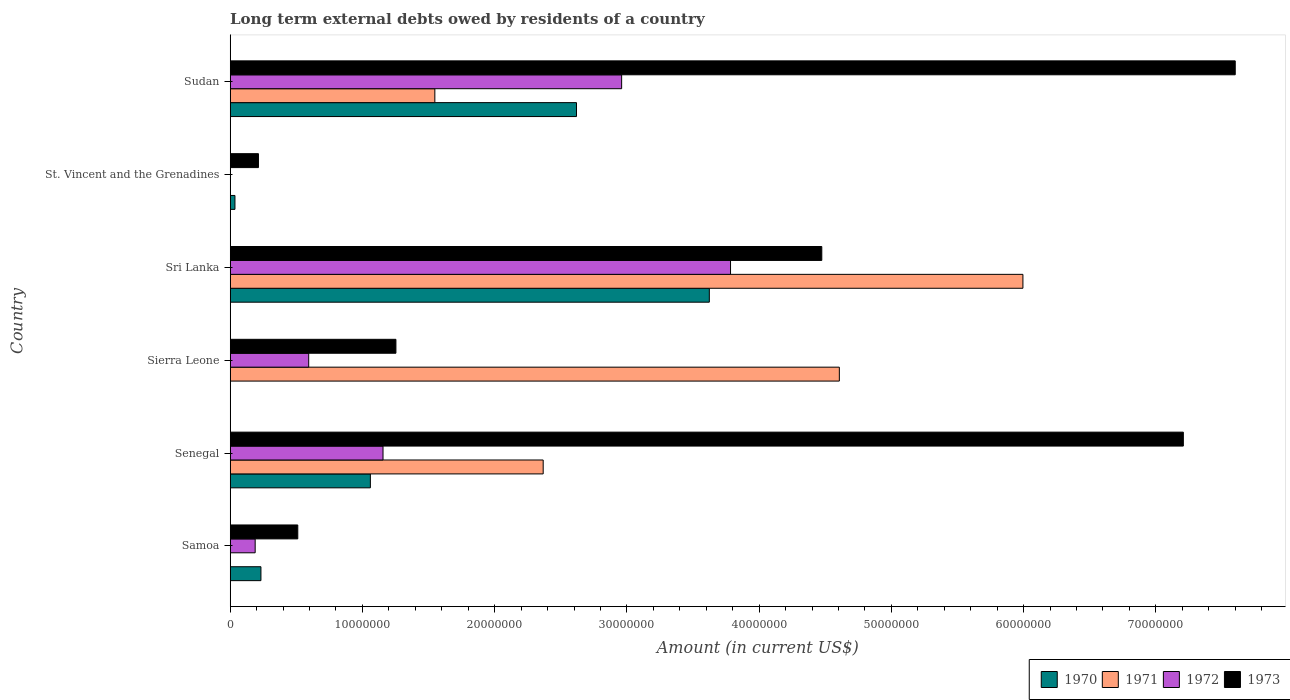Are the number of bars per tick equal to the number of legend labels?
Provide a succinct answer. No. How many bars are there on the 6th tick from the top?
Make the answer very short. 3. How many bars are there on the 3rd tick from the bottom?
Ensure brevity in your answer.  3. What is the label of the 4th group of bars from the top?
Make the answer very short. Sierra Leone. What is the amount of long-term external debts owed by residents in 1973 in Sudan?
Offer a very short reply. 7.60e+07. Across all countries, what is the maximum amount of long-term external debts owed by residents in 1970?
Make the answer very short. 3.62e+07. Across all countries, what is the minimum amount of long-term external debts owed by residents in 1970?
Give a very brief answer. 0. In which country was the amount of long-term external debts owed by residents in 1973 maximum?
Keep it short and to the point. Sudan. What is the total amount of long-term external debts owed by residents in 1971 in the graph?
Offer a very short reply. 1.45e+08. What is the difference between the amount of long-term external debts owed by residents in 1973 in Samoa and that in Sierra Leone?
Provide a succinct answer. -7.42e+06. What is the difference between the amount of long-term external debts owed by residents in 1973 in Sierra Leone and the amount of long-term external debts owed by residents in 1970 in Sri Lanka?
Your answer should be very brief. -2.37e+07. What is the average amount of long-term external debts owed by residents in 1970 per country?
Give a very brief answer. 1.26e+07. What is the difference between the amount of long-term external debts owed by residents in 1971 and amount of long-term external debts owed by residents in 1972 in Sri Lanka?
Your answer should be very brief. 2.21e+07. What is the ratio of the amount of long-term external debts owed by residents in 1972 in St. Vincent and the Grenadines to that in Sudan?
Provide a succinct answer. 0. Is the amount of long-term external debts owed by residents in 1970 in Sri Lanka less than that in Sudan?
Ensure brevity in your answer.  No. What is the difference between the highest and the second highest amount of long-term external debts owed by residents in 1972?
Offer a very short reply. 8.23e+06. What is the difference between the highest and the lowest amount of long-term external debts owed by residents in 1973?
Make the answer very short. 7.39e+07. In how many countries, is the amount of long-term external debts owed by residents in 1971 greater than the average amount of long-term external debts owed by residents in 1971 taken over all countries?
Your answer should be compact. 2. Is the sum of the amount of long-term external debts owed by residents in 1972 in Samoa and Senegal greater than the maximum amount of long-term external debts owed by residents in 1970 across all countries?
Your answer should be very brief. No. Is it the case that in every country, the sum of the amount of long-term external debts owed by residents in 1971 and amount of long-term external debts owed by residents in 1973 is greater than the sum of amount of long-term external debts owed by residents in 1970 and amount of long-term external debts owed by residents in 1972?
Give a very brief answer. No. Is it the case that in every country, the sum of the amount of long-term external debts owed by residents in 1972 and amount of long-term external debts owed by residents in 1971 is greater than the amount of long-term external debts owed by residents in 1970?
Your answer should be very brief. No. How many bars are there?
Your answer should be compact. 22. What is the difference between two consecutive major ticks on the X-axis?
Offer a very short reply. 1.00e+07. Are the values on the major ticks of X-axis written in scientific E-notation?
Offer a terse response. No. Does the graph contain any zero values?
Offer a very short reply. Yes. Does the graph contain grids?
Your answer should be very brief. No. How are the legend labels stacked?
Your answer should be compact. Horizontal. What is the title of the graph?
Your answer should be compact. Long term external debts owed by residents of a country. Does "1965" appear as one of the legend labels in the graph?
Ensure brevity in your answer.  No. What is the label or title of the Y-axis?
Offer a terse response. Country. What is the Amount (in current US$) in 1970 in Samoa?
Provide a succinct answer. 2.32e+06. What is the Amount (in current US$) of 1971 in Samoa?
Provide a short and direct response. 0. What is the Amount (in current US$) of 1972 in Samoa?
Your response must be concise. 1.89e+06. What is the Amount (in current US$) of 1973 in Samoa?
Provide a short and direct response. 5.11e+06. What is the Amount (in current US$) in 1970 in Senegal?
Give a very brief answer. 1.06e+07. What is the Amount (in current US$) in 1971 in Senegal?
Provide a short and direct response. 2.37e+07. What is the Amount (in current US$) in 1972 in Senegal?
Keep it short and to the point. 1.16e+07. What is the Amount (in current US$) of 1973 in Senegal?
Make the answer very short. 7.21e+07. What is the Amount (in current US$) of 1970 in Sierra Leone?
Your response must be concise. 0. What is the Amount (in current US$) of 1971 in Sierra Leone?
Provide a short and direct response. 4.61e+07. What is the Amount (in current US$) in 1972 in Sierra Leone?
Your answer should be very brief. 5.94e+06. What is the Amount (in current US$) of 1973 in Sierra Leone?
Provide a short and direct response. 1.25e+07. What is the Amount (in current US$) in 1970 in Sri Lanka?
Make the answer very short. 3.62e+07. What is the Amount (in current US$) of 1971 in Sri Lanka?
Give a very brief answer. 5.99e+07. What is the Amount (in current US$) in 1972 in Sri Lanka?
Provide a succinct answer. 3.78e+07. What is the Amount (in current US$) in 1973 in Sri Lanka?
Make the answer very short. 4.47e+07. What is the Amount (in current US$) in 1970 in St. Vincent and the Grenadines?
Ensure brevity in your answer.  3.60e+05. What is the Amount (in current US$) of 1971 in St. Vincent and the Grenadines?
Give a very brief answer. 3000. What is the Amount (in current US$) in 1972 in St. Vincent and the Grenadines?
Provide a succinct answer. 1.50e+04. What is the Amount (in current US$) of 1973 in St. Vincent and the Grenadines?
Your response must be concise. 2.14e+06. What is the Amount (in current US$) in 1970 in Sudan?
Your answer should be compact. 2.62e+07. What is the Amount (in current US$) in 1971 in Sudan?
Your answer should be compact. 1.55e+07. What is the Amount (in current US$) of 1972 in Sudan?
Offer a very short reply. 2.96e+07. What is the Amount (in current US$) in 1973 in Sudan?
Your answer should be very brief. 7.60e+07. Across all countries, what is the maximum Amount (in current US$) in 1970?
Your answer should be compact. 3.62e+07. Across all countries, what is the maximum Amount (in current US$) in 1971?
Provide a short and direct response. 5.99e+07. Across all countries, what is the maximum Amount (in current US$) in 1972?
Give a very brief answer. 3.78e+07. Across all countries, what is the maximum Amount (in current US$) in 1973?
Ensure brevity in your answer.  7.60e+07. Across all countries, what is the minimum Amount (in current US$) of 1971?
Your response must be concise. 0. Across all countries, what is the minimum Amount (in current US$) in 1972?
Your answer should be very brief. 1.50e+04. Across all countries, what is the minimum Amount (in current US$) in 1973?
Offer a terse response. 2.14e+06. What is the total Amount (in current US$) of 1970 in the graph?
Your answer should be compact. 7.57e+07. What is the total Amount (in current US$) of 1971 in the graph?
Offer a terse response. 1.45e+08. What is the total Amount (in current US$) of 1972 in the graph?
Offer a terse response. 8.68e+07. What is the total Amount (in current US$) in 1973 in the graph?
Provide a short and direct response. 2.13e+08. What is the difference between the Amount (in current US$) of 1970 in Samoa and that in Senegal?
Your answer should be very brief. -8.28e+06. What is the difference between the Amount (in current US$) in 1972 in Samoa and that in Senegal?
Make the answer very short. -9.67e+06. What is the difference between the Amount (in current US$) in 1973 in Samoa and that in Senegal?
Your answer should be very brief. -6.70e+07. What is the difference between the Amount (in current US$) in 1972 in Samoa and that in Sierra Leone?
Your response must be concise. -4.05e+06. What is the difference between the Amount (in current US$) of 1973 in Samoa and that in Sierra Leone?
Ensure brevity in your answer.  -7.42e+06. What is the difference between the Amount (in current US$) of 1970 in Samoa and that in Sri Lanka?
Offer a terse response. -3.39e+07. What is the difference between the Amount (in current US$) of 1972 in Samoa and that in Sri Lanka?
Your answer should be very brief. -3.59e+07. What is the difference between the Amount (in current US$) in 1973 in Samoa and that in Sri Lanka?
Your answer should be compact. -3.96e+07. What is the difference between the Amount (in current US$) of 1970 in Samoa and that in St. Vincent and the Grenadines?
Your answer should be compact. 1.96e+06. What is the difference between the Amount (in current US$) of 1972 in Samoa and that in St. Vincent and the Grenadines?
Provide a short and direct response. 1.87e+06. What is the difference between the Amount (in current US$) in 1973 in Samoa and that in St. Vincent and the Grenadines?
Your answer should be compact. 2.97e+06. What is the difference between the Amount (in current US$) in 1970 in Samoa and that in Sudan?
Your response must be concise. -2.39e+07. What is the difference between the Amount (in current US$) in 1972 in Samoa and that in Sudan?
Keep it short and to the point. -2.77e+07. What is the difference between the Amount (in current US$) of 1973 in Samoa and that in Sudan?
Provide a succinct answer. -7.09e+07. What is the difference between the Amount (in current US$) of 1971 in Senegal and that in Sierra Leone?
Keep it short and to the point. -2.24e+07. What is the difference between the Amount (in current US$) in 1972 in Senegal and that in Sierra Leone?
Your answer should be compact. 5.62e+06. What is the difference between the Amount (in current US$) in 1973 in Senegal and that in Sierra Leone?
Ensure brevity in your answer.  5.95e+07. What is the difference between the Amount (in current US$) in 1970 in Senegal and that in Sri Lanka?
Ensure brevity in your answer.  -2.56e+07. What is the difference between the Amount (in current US$) of 1971 in Senegal and that in Sri Lanka?
Your answer should be compact. -3.63e+07. What is the difference between the Amount (in current US$) in 1972 in Senegal and that in Sri Lanka?
Offer a terse response. -2.63e+07. What is the difference between the Amount (in current US$) in 1973 in Senegal and that in Sri Lanka?
Your response must be concise. 2.73e+07. What is the difference between the Amount (in current US$) of 1970 in Senegal and that in St. Vincent and the Grenadines?
Your answer should be very brief. 1.02e+07. What is the difference between the Amount (in current US$) of 1971 in Senegal and that in St. Vincent and the Grenadines?
Offer a very short reply. 2.37e+07. What is the difference between the Amount (in current US$) of 1972 in Senegal and that in St. Vincent and the Grenadines?
Provide a short and direct response. 1.15e+07. What is the difference between the Amount (in current US$) of 1973 in Senegal and that in St. Vincent and the Grenadines?
Provide a short and direct response. 6.99e+07. What is the difference between the Amount (in current US$) of 1970 in Senegal and that in Sudan?
Your answer should be compact. -1.56e+07. What is the difference between the Amount (in current US$) in 1971 in Senegal and that in Sudan?
Make the answer very short. 8.19e+06. What is the difference between the Amount (in current US$) of 1972 in Senegal and that in Sudan?
Your answer should be compact. -1.80e+07. What is the difference between the Amount (in current US$) in 1973 in Senegal and that in Sudan?
Provide a succinct answer. -3.92e+06. What is the difference between the Amount (in current US$) of 1971 in Sierra Leone and that in Sri Lanka?
Your answer should be compact. -1.39e+07. What is the difference between the Amount (in current US$) in 1972 in Sierra Leone and that in Sri Lanka?
Offer a very short reply. -3.19e+07. What is the difference between the Amount (in current US$) of 1973 in Sierra Leone and that in Sri Lanka?
Give a very brief answer. -3.22e+07. What is the difference between the Amount (in current US$) of 1971 in Sierra Leone and that in St. Vincent and the Grenadines?
Your answer should be very brief. 4.61e+07. What is the difference between the Amount (in current US$) in 1972 in Sierra Leone and that in St. Vincent and the Grenadines?
Ensure brevity in your answer.  5.92e+06. What is the difference between the Amount (in current US$) in 1973 in Sierra Leone and that in St. Vincent and the Grenadines?
Your response must be concise. 1.04e+07. What is the difference between the Amount (in current US$) of 1971 in Sierra Leone and that in Sudan?
Your answer should be very brief. 3.06e+07. What is the difference between the Amount (in current US$) in 1972 in Sierra Leone and that in Sudan?
Your answer should be very brief. -2.37e+07. What is the difference between the Amount (in current US$) of 1973 in Sierra Leone and that in Sudan?
Ensure brevity in your answer.  -6.35e+07. What is the difference between the Amount (in current US$) of 1970 in Sri Lanka and that in St. Vincent and the Grenadines?
Ensure brevity in your answer.  3.59e+07. What is the difference between the Amount (in current US$) of 1971 in Sri Lanka and that in St. Vincent and the Grenadines?
Give a very brief answer. 5.99e+07. What is the difference between the Amount (in current US$) in 1972 in Sri Lanka and that in St. Vincent and the Grenadines?
Your answer should be very brief. 3.78e+07. What is the difference between the Amount (in current US$) in 1973 in Sri Lanka and that in St. Vincent and the Grenadines?
Your response must be concise. 4.26e+07. What is the difference between the Amount (in current US$) in 1970 in Sri Lanka and that in Sudan?
Provide a short and direct response. 1.00e+07. What is the difference between the Amount (in current US$) of 1971 in Sri Lanka and that in Sudan?
Give a very brief answer. 4.45e+07. What is the difference between the Amount (in current US$) in 1972 in Sri Lanka and that in Sudan?
Provide a succinct answer. 8.23e+06. What is the difference between the Amount (in current US$) in 1973 in Sri Lanka and that in Sudan?
Offer a terse response. -3.13e+07. What is the difference between the Amount (in current US$) of 1970 in St. Vincent and the Grenadines and that in Sudan?
Make the answer very short. -2.58e+07. What is the difference between the Amount (in current US$) of 1971 in St. Vincent and the Grenadines and that in Sudan?
Offer a very short reply. -1.55e+07. What is the difference between the Amount (in current US$) of 1972 in St. Vincent and the Grenadines and that in Sudan?
Your answer should be compact. -2.96e+07. What is the difference between the Amount (in current US$) in 1973 in St. Vincent and the Grenadines and that in Sudan?
Your answer should be compact. -7.39e+07. What is the difference between the Amount (in current US$) in 1970 in Samoa and the Amount (in current US$) in 1971 in Senegal?
Keep it short and to the point. -2.13e+07. What is the difference between the Amount (in current US$) of 1970 in Samoa and the Amount (in current US$) of 1972 in Senegal?
Provide a short and direct response. -9.23e+06. What is the difference between the Amount (in current US$) of 1970 in Samoa and the Amount (in current US$) of 1973 in Senegal?
Your answer should be compact. -6.98e+07. What is the difference between the Amount (in current US$) in 1972 in Samoa and the Amount (in current US$) in 1973 in Senegal?
Offer a terse response. -7.02e+07. What is the difference between the Amount (in current US$) in 1970 in Samoa and the Amount (in current US$) in 1971 in Sierra Leone?
Keep it short and to the point. -4.37e+07. What is the difference between the Amount (in current US$) of 1970 in Samoa and the Amount (in current US$) of 1972 in Sierra Leone?
Offer a very short reply. -3.61e+06. What is the difference between the Amount (in current US$) in 1970 in Samoa and the Amount (in current US$) in 1973 in Sierra Leone?
Ensure brevity in your answer.  -1.02e+07. What is the difference between the Amount (in current US$) of 1972 in Samoa and the Amount (in current US$) of 1973 in Sierra Leone?
Make the answer very short. -1.06e+07. What is the difference between the Amount (in current US$) of 1970 in Samoa and the Amount (in current US$) of 1971 in Sri Lanka?
Your response must be concise. -5.76e+07. What is the difference between the Amount (in current US$) of 1970 in Samoa and the Amount (in current US$) of 1972 in Sri Lanka?
Your answer should be very brief. -3.55e+07. What is the difference between the Amount (in current US$) in 1970 in Samoa and the Amount (in current US$) in 1973 in Sri Lanka?
Ensure brevity in your answer.  -4.24e+07. What is the difference between the Amount (in current US$) of 1972 in Samoa and the Amount (in current US$) of 1973 in Sri Lanka?
Offer a terse response. -4.28e+07. What is the difference between the Amount (in current US$) of 1970 in Samoa and the Amount (in current US$) of 1971 in St. Vincent and the Grenadines?
Ensure brevity in your answer.  2.32e+06. What is the difference between the Amount (in current US$) of 1970 in Samoa and the Amount (in current US$) of 1972 in St. Vincent and the Grenadines?
Ensure brevity in your answer.  2.31e+06. What is the difference between the Amount (in current US$) in 1970 in Samoa and the Amount (in current US$) in 1973 in St. Vincent and the Grenadines?
Keep it short and to the point. 1.88e+05. What is the difference between the Amount (in current US$) of 1972 in Samoa and the Amount (in current US$) of 1973 in St. Vincent and the Grenadines?
Keep it short and to the point. -2.48e+05. What is the difference between the Amount (in current US$) of 1970 in Samoa and the Amount (in current US$) of 1971 in Sudan?
Your answer should be very brief. -1.32e+07. What is the difference between the Amount (in current US$) of 1970 in Samoa and the Amount (in current US$) of 1972 in Sudan?
Give a very brief answer. -2.73e+07. What is the difference between the Amount (in current US$) in 1970 in Samoa and the Amount (in current US$) in 1973 in Sudan?
Your response must be concise. -7.37e+07. What is the difference between the Amount (in current US$) in 1972 in Samoa and the Amount (in current US$) in 1973 in Sudan?
Provide a short and direct response. -7.41e+07. What is the difference between the Amount (in current US$) of 1970 in Senegal and the Amount (in current US$) of 1971 in Sierra Leone?
Offer a terse response. -3.55e+07. What is the difference between the Amount (in current US$) of 1970 in Senegal and the Amount (in current US$) of 1972 in Sierra Leone?
Ensure brevity in your answer.  4.66e+06. What is the difference between the Amount (in current US$) in 1970 in Senegal and the Amount (in current US$) in 1973 in Sierra Leone?
Your answer should be compact. -1.93e+06. What is the difference between the Amount (in current US$) in 1971 in Senegal and the Amount (in current US$) in 1972 in Sierra Leone?
Keep it short and to the point. 1.77e+07. What is the difference between the Amount (in current US$) in 1971 in Senegal and the Amount (in current US$) in 1973 in Sierra Leone?
Offer a terse response. 1.11e+07. What is the difference between the Amount (in current US$) in 1972 in Senegal and the Amount (in current US$) in 1973 in Sierra Leone?
Your answer should be very brief. -9.76e+05. What is the difference between the Amount (in current US$) in 1970 in Senegal and the Amount (in current US$) in 1971 in Sri Lanka?
Keep it short and to the point. -4.93e+07. What is the difference between the Amount (in current US$) of 1970 in Senegal and the Amount (in current US$) of 1972 in Sri Lanka?
Ensure brevity in your answer.  -2.72e+07. What is the difference between the Amount (in current US$) in 1970 in Senegal and the Amount (in current US$) in 1973 in Sri Lanka?
Provide a succinct answer. -3.41e+07. What is the difference between the Amount (in current US$) in 1971 in Senegal and the Amount (in current US$) in 1972 in Sri Lanka?
Offer a very short reply. -1.42e+07. What is the difference between the Amount (in current US$) in 1971 in Senegal and the Amount (in current US$) in 1973 in Sri Lanka?
Ensure brevity in your answer.  -2.11e+07. What is the difference between the Amount (in current US$) of 1972 in Senegal and the Amount (in current US$) of 1973 in Sri Lanka?
Provide a short and direct response. -3.32e+07. What is the difference between the Amount (in current US$) of 1970 in Senegal and the Amount (in current US$) of 1971 in St. Vincent and the Grenadines?
Your response must be concise. 1.06e+07. What is the difference between the Amount (in current US$) of 1970 in Senegal and the Amount (in current US$) of 1972 in St. Vincent and the Grenadines?
Keep it short and to the point. 1.06e+07. What is the difference between the Amount (in current US$) of 1970 in Senegal and the Amount (in current US$) of 1973 in St. Vincent and the Grenadines?
Your answer should be compact. 8.46e+06. What is the difference between the Amount (in current US$) in 1971 in Senegal and the Amount (in current US$) in 1972 in St. Vincent and the Grenadines?
Ensure brevity in your answer.  2.37e+07. What is the difference between the Amount (in current US$) of 1971 in Senegal and the Amount (in current US$) of 1973 in St. Vincent and the Grenadines?
Provide a short and direct response. 2.15e+07. What is the difference between the Amount (in current US$) of 1972 in Senegal and the Amount (in current US$) of 1973 in St. Vincent and the Grenadines?
Give a very brief answer. 9.42e+06. What is the difference between the Amount (in current US$) in 1970 in Senegal and the Amount (in current US$) in 1971 in Sudan?
Your answer should be very brief. -4.88e+06. What is the difference between the Amount (in current US$) in 1970 in Senegal and the Amount (in current US$) in 1972 in Sudan?
Your response must be concise. -1.90e+07. What is the difference between the Amount (in current US$) of 1970 in Senegal and the Amount (in current US$) of 1973 in Sudan?
Keep it short and to the point. -6.54e+07. What is the difference between the Amount (in current US$) in 1971 in Senegal and the Amount (in current US$) in 1972 in Sudan?
Keep it short and to the point. -5.93e+06. What is the difference between the Amount (in current US$) in 1971 in Senegal and the Amount (in current US$) in 1973 in Sudan?
Give a very brief answer. -5.23e+07. What is the difference between the Amount (in current US$) of 1972 in Senegal and the Amount (in current US$) of 1973 in Sudan?
Provide a short and direct response. -6.44e+07. What is the difference between the Amount (in current US$) in 1971 in Sierra Leone and the Amount (in current US$) in 1972 in Sri Lanka?
Offer a terse response. 8.23e+06. What is the difference between the Amount (in current US$) of 1971 in Sierra Leone and the Amount (in current US$) of 1973 in Sri Lanka?
Ensure brevity in your answer.  1.33e+06. What is the difference between the Amount (in current US$) of 1972 in Sierra Leone and the Amount (in current US$) of 1973 in Sri Lanka?
Ensure brevity in your answer.  -3.88e+07. What is the difference between the Amount (in current US$) in 1971 in Sierra Leone and the Amount (in current US$) in 1972 in St. Vincent and the Grenadines?
Provide a succinct answer. 4.60e+07. What is the difference between the Amount (in current US$) of 1971 in Sierra Leone and the Amount (in current US$) of 1973 in St. Vincent and the Grenadines?
Your answer should be very brief. 4.39e+07. What is the difference between the Amount (in current US$) of 1972 in Sierra Leone and the Amount (in current US$) of 1973 in St. Vincent and the Grenadines?
Keep it short and to the point. 3.80e+06. What is the difference between the Amount (in current US$) of 1971 in Sierra Leone and the Amount (in current US$) of 1972 in Sudan?
Your response must be concise. 1.65e+07. What is the difference between the Amount (in current US$) of 1971 in Sierra Leone and the Amount (in current US$) of 1973 in Sudan?
Keep it short and to the point. -2.99e+07. What is the difference between the Amount (in current US$) of 1972 in Sierra Leone and the Amount (in current US$) of 1973 in Sudan?
Offer a terse response. -7.01e+07. What is the difference between the Amount (in current US$) of 1970 in Sri Lanka and the Amount (in current US$) of 1971 in St. Vincent and the Grenadines?
Your answer should be very brief. 3.62e+07. What is the difference between the Amount (in current US$) of 1970 in Sri Lanka and the Amount (in current US$) of 1972 in St. Vincent and the Grenadines?
Offer a very short reply. 3.62e+07. What is the difference between the Amount (in current US$) in 1970 in Sri Lanka and the Amount (in current US$) in 1973 in St. Vincent and the Grenadines?
Your answer should be very brief. 3.41e+07. What is the difference between the Amount (in current US$) in 1971 in Sri Lanka and the Amount (in current US$) in 1972 in St. Vincent and the Grenadines?
Offer a terse response. 5.99e+07. What is the difference between the Amount (in current US$) of 1971 in Sri Lanka and the Amount (in current US$) of 1973 in St. Vincent and the Grenadines?
Provide a short and direct response. 5.78e+07. What is the difference between the Amount (in current US$) of 1972 in Sri Lanka and the Amount (in current US$) of 1973 in St. Vincent and the Grenadines?
Provide a short and direct response. 3.57e+07. What is the difference between the Amount (in current US$) in 1970 in Sri Lanka and the Amount (in current US$) in 1971 in Sudan?
Offer a very short reply. 2.08e+07. What is the difference between the Amount (in current US$) in 1970 in Sri Lanka and the Amount (in current US$) in 1972 in Sudan?
Keep it short and to the point. 6.63e+06. What is the difference between the Amount (in current US$) in 1970 in Sri Lanka and the Amount (in current US$) in 1973 in Sudan?
Your answer should be compact. -3.98e+07. What is the difference between the Amount (in current US$) in 1971 in Sri Lanka and the Amount (in current US$) in 1972 in Sudan?
Your response must be concise. 3.03e+07. What is the difference between the Amount (in current US$) in 1971 in Sri Lanka and the Amount (in current US$) in 1973 in Sudan?
Offer a terse response. -1.61e+07. What is the difference between the Amount (in current US$) in 1972 in Sri Lanka and the Amount (in current US$) in 1973 in Sudan?
Ensure brevity in your answer.  -3.82e+07. What is the difference between the Amount (in current US$) of 1970 in St. Vincent and the Grenadines and the Amount (in current US$) of 1971 in Sudan?
Give a very brief answer. -1.51e+07. What is the difference between the Amount (in current US$) of 1970 in St. Vincent and the Grenadines and the Amount (in current US$) of 1972 in Sudan?
Your answer should be compact. -2.92e+07. What is the difference between the Amount (in current US$) in 1970 in St. Vincent and the Grenadines and the Amount (in current US$) in 1973 in Sudan?
Offer a very short reply. -7.56e+07. What is the difference between the Amount (in current US$) of 1971 in St. Vincent and the Grenadines and the Amount (in current US$) of 1972 in Sudan?
Your response must be concise. -2.96e+07. What is the difference between the Amount (in current US$) of 1971 in St. Vincent and the Grenadines and the Amount (in current US$) of 1973 in Sudan?
Your answer should be very brief. -7.60e+07. What is the difference between the Amount (in current US$) in 1972 in St. Vincent and the Grenadines and the Amount (in current US$) in 1973 in Sudan?
Offer a terse response. -7.60e+07. What is the average Amount (in current US$) of 1970 per country?
Keep it short and to the point. 1.26e+07. What is the average Amount (in current US$) in 1971 per country?
Your answer should be very brief. 2.42e+07. What is the average Amount (in current US$) of 1972 per country?
Keep it short and to the point. 1.45e+07. What is the average Amount (in current US$) in 1973 per country?
Your answer should be very brief. 3.54e+07. What is the difference between the Amount (in current US$) in 1970 and Amount (in current US$) in 1972 in Samoa?
Your response must be concise. 4.36e+05. What is the difference between the Amount (in current US$) of 1970 and Amount (in current US$) of 1973 in Samoa?
Keep it short and to the point. -2.79e+06. What is the difference between the Amount (in current US$) of 1972 and Amount (in current US$) of 1973 in Samoa?
Your answer should be very brief. -3.22e+06. What is the difference between the Amount (in current US$) of 1970 and Amount (in current US$) of 1971 in Senegal?
Offer a terse response. -1.31e+07. What is the difference between the Amount (in current US$) of 1970 and Amount (in current US$) of 1972 in Senegal?
Your response must be concise. -9.56e+05. What is the difference between the Amount (in current US$) in 1970 and Amount (in current US$) in 1973 in Senegal?
Ensure brevity in your answer.  -6.15e+07. What is the difference between the Amount (in current US$) of 1971 and Amount (in current US$) of 1972 in Senegal?
Make the answer very short. 1.21e+07. What is the difference between the Amount (in current US$) in 1971 and Amount (in current US$) in 1973 in Senegal?
Provide a short and direct response. -4.84e+07. What is the difference between the Amount (in current US$) in 1972 and Amount (in current US$) in 1973 in Senegal?
Your answer should be very brief. -6.05e+07. What is the difference between the Amount (in current US$) of 1971 and Amount (in current US$) of 1972 in Sierra Leone?
Your answer should be very brief. 4.01e+07. What is the difference between the Amount (in current US$) of 1971 and Amount (in current US$) of 1973 in Sierra Leone?
Ensure brevity in your answer.  3.35e+07. What is the difference between the Amount (in current US$) of 1972 and Amount (in current US$) of 1973 in Sierra Leone?
Offer a very short reply. -6.60e+06. What is the difference between the Amount (in current US$) of 1970 and Amount (in current US$) of 1971 in Sri Lanka?
Offer a terse response. -2.37e+07. What is the difference between the Amount (in current US$) in 1970 and Amount (in current US$) in 1972 in Sri Lanka?
Give a very brief answer. -1.60e+06. What is the difference between the Amount (in current US$) in 1970 and Amount (in current US$) in 1973 in Sri Lanka?
Give a very brief answer. -8.50e+06. What is the difference between the Amount (in current US$) in 1971 and Amount (in current US$) in 1972 in Sri Lanka?
Your response must be concise. 2.21e+07. What is the difference between the Amount (in current US$) in 1971 and Amount (in current US$) in 1973 in Sri Lanka?
Your answer should be very brief. 1.52e+07. What is the difference between the Amount (in current US$) in 1972 and Amount (in current US$) in 1973 in Sri Lanka?
Give a very brief answer. -6.90e+06. What is the difference between the Amount (in current US$) of 1970 and Amount (in current US$) of 1971 in St. Vincent and the Grenadines?
Provide a succinct answer. 3.57e+05. What is the difference between the Amount (in current US$) in 1970 and Amount (in current US$) in 1972 in St. Vincent and the Grenadines?
Make the answer very short. 3.45e+05. What is the difference between the Amount (in current US$) in 1970 and Amount (in current US$) in 1973 in St. Vincent and the Grenadines?
Your response must be concise. -1.78e+06. What is the difference between the Amount (in current US$) in 1971 and Amount (in current US$) in 1972 in St. Vincent and the Grenadines?
Make the answer very short. -1.20e+04. What is the difference between the Amount (in current US$) of 1971 and Amount (in current US$) of 1973 in St. Vincent and the Grenadines?
Keep it short and to the point. -2.13e+06. What is the difference between the Amount (in current US$) in 1972 and Amount (in current US$) in 1973 in St. Vincent and the Grenadines?
Provide a succinct answer. -2.12e+06. What is the difference between the Amount (in current US$) of 1970 and Amount (in current US$) of 1971 in Sudan?
Your response must be concise. 1.07e+07. What is the difference between the Amount (in current US$) of 1970 and Amount (in current US$) of 1972 in Sudan?
Give a very brief answer. -3.41e+06. What is the difference between the Amount (in current US$) in 1970 and Amount (in current US$) in 1973 in Sudan?
Your response must be concise. -4.98e+07. What is the difference between the Amount (in current US$) in 1971 and Amount (in current US$) in 1972 in Sudan?
Offer a terse response. -1.41e+07. What is the difference between the Amount (in current US$) in 1971 and Amount (in current US$) in 1973 in Sudan?
Your answer should be compact. -6.05e+07. What is the difference between the Amount (in current US$) in 1972 and Amount (in current US$) in 1973 in Sudan?
Your answer should be very brief. -4.64e+07. What is the ratio of the Amount (in current US$) of 1970 in Samoa to that in Senegal?
Provide a succinct answer. 0.22. What is the ratio of the Amount (in current US$) of 1972 in Samoa to that in Senegal?
Provide a succinct answer. 0.16. What is the ratio of the Amount (in current US$) of 1973 in Samoa to that in Senegal?
Offer a very short reply. 0.07. What is the ratio of the Amount (in current US$) of 1972 in Samoa to that in Sierra Leone?
Offer a very short reply. 0.32. What is the ratio of the Amount (in current US$) in 1973 in Samoa to that in Sierra Leone?
Offer a terse response. 0.41. What is the ratio of the Amount (in current US$) of 1970 in Samoa to that in Sri Lanka?
Offer a terse response. 0.06. What is the ratio of the Amount (in current US$) of 1972 in Samoa to that in Sri Lanka?
Your response must be concise. 0.05. What is the ratio of the Amount (in current US$) in 1973 in Samoa to that in Sri Lanka?
Make the answer very short. 0.11. What is the ratio of the Amount (in current US$) of 1970 in Samoa to that in St. Vincent and the Grenadines?
Ensure brevity in your answer.  6.46. What is the ratio of the Amount (in current US$) of 1972 in Samoa to that in St. Vincent and the Grenadines?
Your response must be concise. 125.93. What is the ratio of the Amount (in current US$) in 1973 in Samoa to that in St. Vincent and the Grenadines?
Give a very brief answer. 2.39. What is the ratio of the Amount (in current US$) in 1970 in Samoa to that in Sudan?
Give a very brief answer. 0.09. What is the ratio of the Amount (in current US$) in 1972 in Samoa to that in Sudan?
Offer a terse response. 0.06. What is the ratio of the Amount (in current US$) of 1973 in Samoa to that in Sudan?
Give a very brief answer. 0.07. What is the ratio of the Amount (in current US$) of 1971 in Senegal to that in Sierra Leone?
Ensure brevity in your answer.  0.51. What is the ratio of the Amount (in current US$) of 1972 in Senegal to that in Sierra Leone?
Make the answer very short. 1.95. What is the ratio of the Amount (in current US$) in 1973 in Senegal to that in Sierra Leone?
Keep it short and to the point. 5.75. What is the ratio of the Amount (in current US$) of 1970 in Senegal to that in Sri Lanka?
Offer a very short reply. 0.29. What is the ratio of the Amount (in current US$) in 1971 in Senegal to that in Sri Lanka?
Offer a terse response. 0.39. What is the ratio of the Amount (in current US$) in 1972 in Senegal to that in Sri Lanka?
Provide a short and direct response. 0.31. What is the ratio of the Amount (in current US$) of 1973 in Senegal to that in Sri Lanka?
Keep it short and to the point. 1.61. What is the ratio of the Amount (in current US$) of 1970 in Senegal to that in St. Vincent and the Grenadines?
Your answer should be compact. 29.45. What is the ratio of the Amount (in current US$) in 1971 in Senegal to that in St. Vincent and the Grenadines?
Ensure brevity in your answer.  7889.67. What is the ratio of the Amount (in current US$) of 1972 in Senegal to that in St. Vincent and the Grenadines?
Give a very brief answer. 770.47. What is the ratio of the Amount (in current US$) of 1973 in Senegal to that in St. Vincent and the Grenadines?
Provide a short and direct response. 33.73. What is the ratio of the Amount (in current US$) in 1970 in Senegal to that in Sudan?
Provide a succinct answer. 0.4. What is the ratio of the Amount (in current US$) in 1971 in Senegal to that in Sudan?
Your response must be concise. 1.53. What is the ratio of the Amount (in current US$) in 1972 in Senegal to that in Sudan?
Make the answer very short. 0.39. What is the ratio of the Amount (in current US$) in 1973 in Senegal to that in Sudan?
Ensure brevity in your answer.  0.95. What is the ratio of the Amount (in current US$) in 1971 in Sierra Leone to that in Sri Lanka?
Provide a succinct answer. 0.77. What is the ratio of the Amount (in current US$) of 1972 in Sierra Leone to that in Sri Lanka?
Keep it short and to the point. 0.16. What is the ratio of the Amount (in current US$) in 1973 in Sierra Leone to that in Sri Lanka?
Make the answer very short. 0.28. What is the ratio of the Amount (in current US$) of 1971 in Sierra Leone to that in St. Vincent and the Grenadines?
Keep it short and to the point. 1.54e+04. What is the ratio of the Amount (in current US$) in 1972 in Sierra Leone to that in St. Vincent and the Grenadines?
Ensure brevity in your answer.  395.8. What is the ratio of the Amount (in current US$) of 1973 in Sierra Leone to that in St. Vincent and the Grenadines?
Your response must be concise. 5.86. What is the ratio of the Amount (in current US$) of 1971 in Sierra Leone to that in Sudan?
Offer a terse response. 2.98. What is the ratio of the Amount (in current US$) in 1972 in Sierra Leone to that in Sudan?
Offer a terse response. 0.2. What is the ratio of the Amount (in current US$) in 1973 in Sierra Leone to that in Sudan?
Provide a short and direct response. 0.16. What is the ratio of the Amount (in current US$) in 1970 in Sri Lanka to that in St. Vincent and the Grenadines?
Make the answer very short. 100.65. What is the ratio of the Amount (in current US$) of 1971 in Sri Lanka to that in St. Vincent and the Grenadines?
Make the answer very short. 2.00e+04. What is the ratio of the Amount (in current US$) of 1972 in Sri Lanka to that in St. Vincent and the Grenadines?
Ensure brevity in your answer.  2522.4. What is the ratio of the Amount (in current US$) in 1973 in Sri Lanka to that in St. Vincent and the Grenadines?
Offer a terse response. 20.93. What is the ratio of the Amount (in current US$) in 1970 in Sri Lanka to that in Sudan?
Your answer should be compact. 1.38. What is the ratio of the Amount (in current US$) in 1971 in Sri Lanka to that in Sudan?
Give a very brief answer. 3.87. What is the ratio of the Amount (in current US$) of 1972 in Sri Lanka to that in Sudan?
Keep it short and to the point. 1.28. What is the ratio of the Amount (in current US$) in 1973 in Sri Lanka to that in Sudan?
Your response must be concise. 0.59. What is the ratio of the Amount (in current US$) of 1970 in St. Vincent and the Grenadines to that in Sudan?
Offer a terse response. 0.01. What is the ratio of the Amount (in current US$) of 1972 in St. Vincent and the Grenadines to that in Sudan?
Your answer should be compact. 0. What is the ratio of the Amount (in current US$) in 1973 in St. Vincent and the Grenadines to that in Sudan?
Ensure brevity in your answer.  0.03. What is the difference between the highest and the second highest Amount (in current US$) in 1970?
Provide a short and direct response. 1.00e+07. What is the difference between the highest and the second highest Amount (in current US$) in 1971?
Give a very brief answer. 1.39e+07. What is the difference between the highest and the second highest Amount (in current US$) in 1972?
Provide a short and direct response. 8.23e+06. What is the difference between the highest and the second highest Amount (in current US$) of 1973?
Your answer should be compact. 3.92e+06. What is the difference between the highest and the lowest Amount (in current US$) in 1970?
Your answer should be very brief. 3.62e+07. What is the difference between the highest and the lowest Amount (in current US$) of 1971?
Your answer should be compact. 5.99e+07. What is the difference between the highest and the lowest Amount (in current US$) of 1972?
Your response must be concise. 3.78e+07. What is the difference between the highest and the lowest Amount (in current US$) of 1973?
Provide a succinct answer. 7.39e+07. 